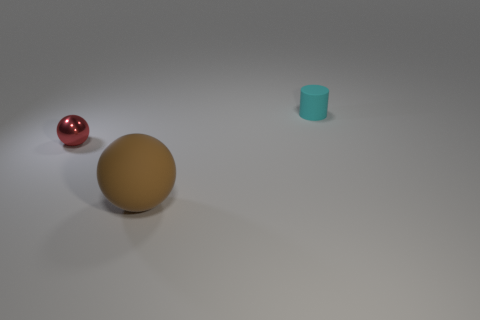Add 2 red things. How many objects exist? 5 Subtract all cylinders. How many objects are left? 2 Add 3 tiny objects. How many tiny objects are left? 5 Add 1 small brown matte spheres. How many small brown matte spheres exist? 1 Subtract 0 purple blocks. How many objects are left? 3 Subtract all metal things. Subtract all small cylinders. How many objects are left? 1 